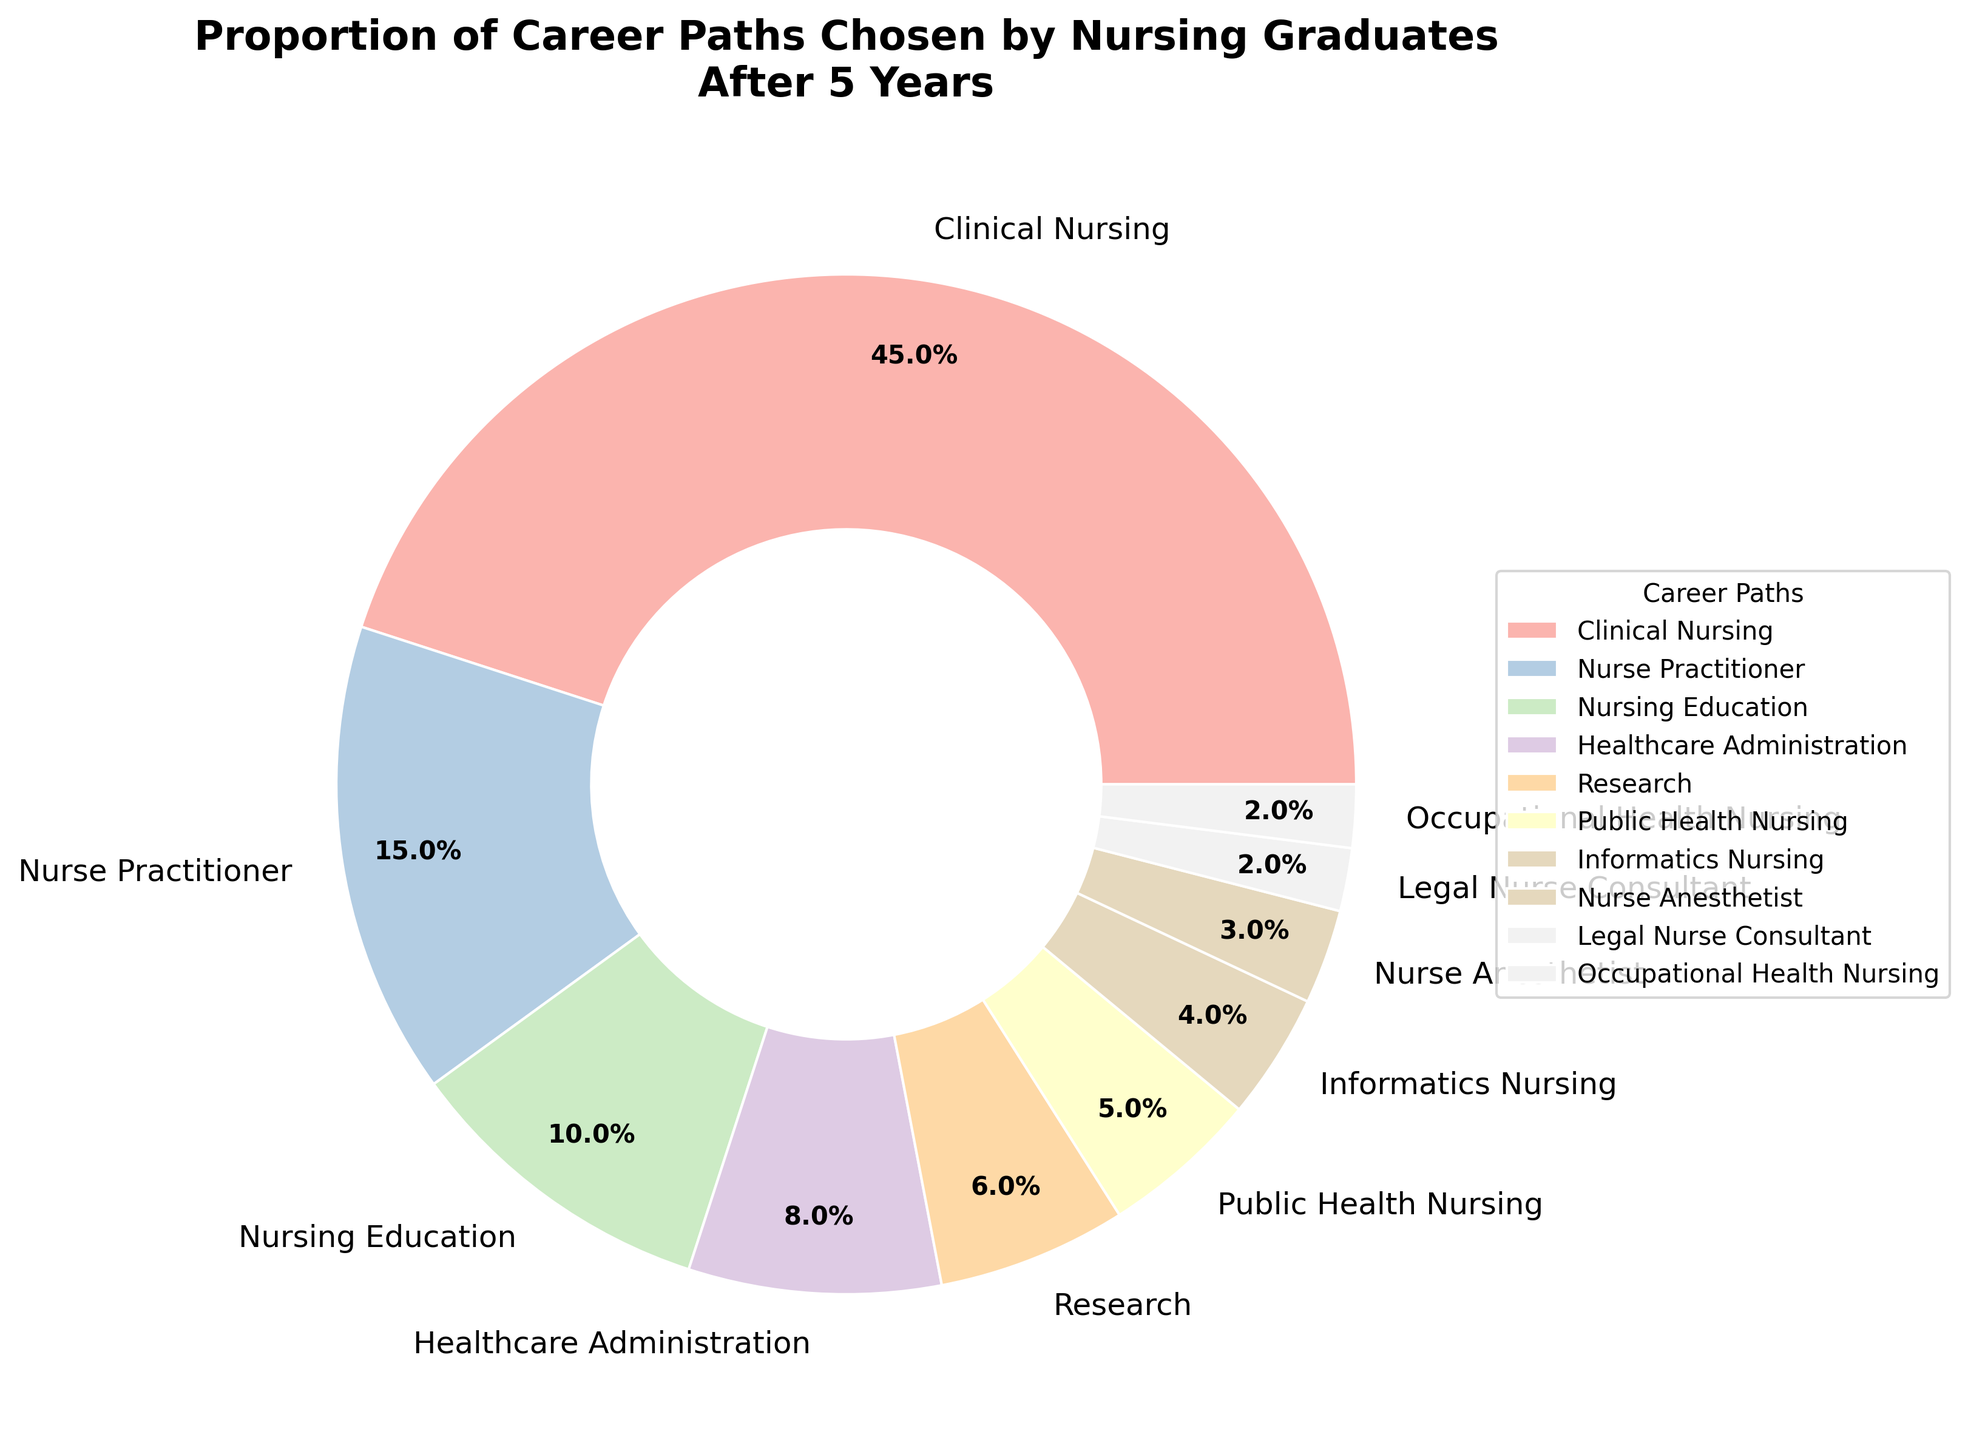Which career path has the highest proportion among nursing graduates five years after graduation? The pie chart visually shows the largest sector, representing "Clinical Nursing." The percentage label confirms it.
Answer: Clinical Nursing What is the combined percentage of graduates who chose Healthcare Administration and Research career paths? According to the pie chart, Healthcare Administration is 8% and Research is 6%. Adding these together, 8% + 6% = 14%.
Answer: 14% How many times larger is the proportion of Clinical Nursing graduates compared to Nurse Anesthetist graduates? Clinical Nursing is 45%, and Nurse Anesthetist is 3%. Divide 45 by 3 to find the ratio: 45 / 3 = 15 times.
Answer: 15 times Which career paths have a proportion of 5% or less? The pie chart shows Public Health Nursing (5%), Informatics Nursing (4%), Nurse Anesthetist (3%), Legal Nurse Consultant (2%), and Occupational Health Nursing (2%).
Answer: Public Health Nursing, Informatics Nursing, Nurse Anesthetist, Legal Nurse Consultant, Occupational Health Nursing Is the percentage of graduates in Nurse Practitioner higher than the combination of Nursing Education and Informatics Nursing? Nurse Practitioner is 15%, Nursing Education is 10%, and Informatics Nursing is 4%. Combined, Nursing Education and Informatics Nursing are 10% + 4% = 14%. Since 15% > 14%, Nurse Practitioner has a higher percentage.
Answer: Yes What is the difference in percentage between the most and least chosen career paths? The most chosen is Clinical Nursing (45%), and the least chosen are Legal Nurse Consultant and Occupational Health Nursing (2% each). The difference is 45% - 2% = 43%.
Answer: 43% How much greater is the proportion of graduates in Nurse Practitioner compared to Public Health Nursing? Nurse Practitioner is 15%, and Public Health Nursing is 5%. The difference is 15% - 5% = 10%.
Answer: 10% Which career path is represented by the smallest wedge in the pie chart? The pie chart shows the smallest wedge corresponding to Legal Nurse Consultant and Occupational Health Nursing, each at 2%.
Answer: Legal Nurse Consultant, Occupational Health Nursing If you combine the percentages for Nursing Education, Healthcare Administration, and Research, do they collectively exceed 20%? Nursing Education is 10%, Healthcare Administration is 8%, and Research is 6%. When combined, 10% + 8% + 6% = 24%, which exceeds 20%.
Answer: Yes What is the total percentage of graduates in roles directly involved in patient care (Clinical Nursing, Nurse Practitioner, Public Health Nursing, Nurse Anesthetist)? Adding the percentages: Clinical Nursing (45%), Nurse Practitioner (15%), Public Health Nursing (5%), and Nurse Anesthetist (3%), we get 45% + 15% + 5% + 3% = 68%.
Answer: 68% 